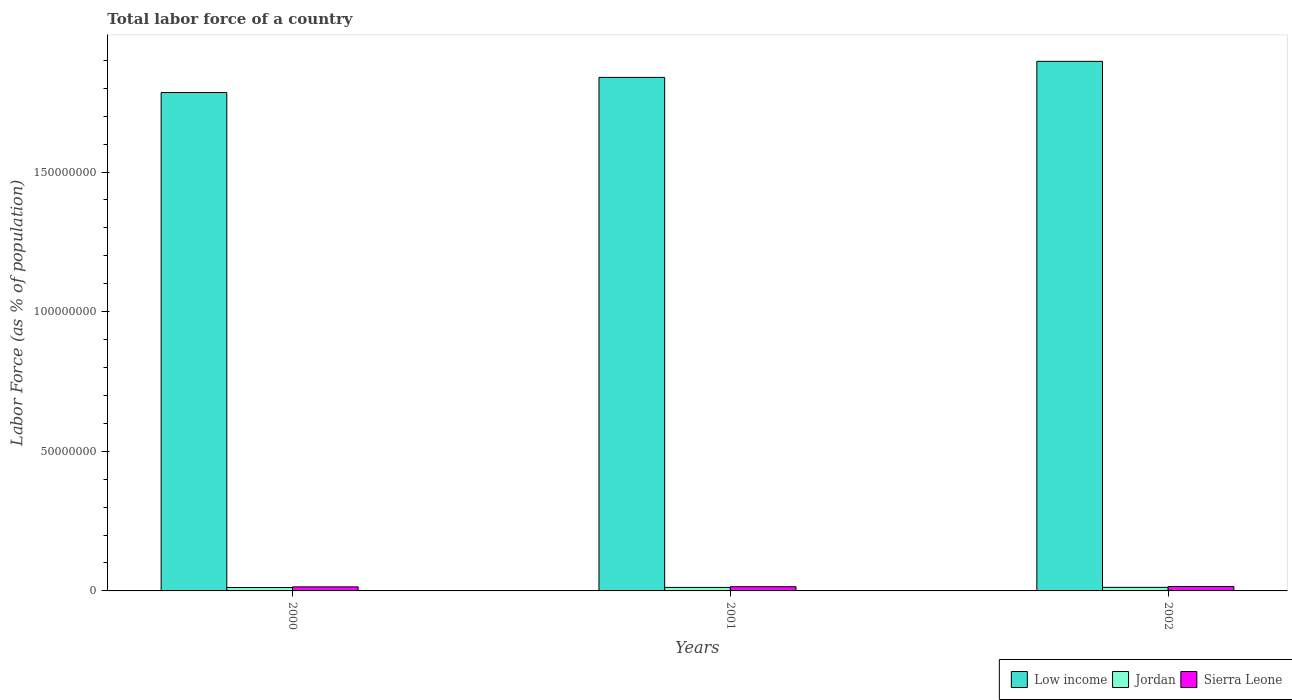Are the number of bars per tick equal to the number of legend labels?
Your answer should be compact. Yes. Are the number of bars on each tick of the X-axis equal?
Give a very brief answer. Yes. What is the label of the 2nd group of bars from the left?
Ensure brevity in your answer.  2001. What is the percentage of labor force in Sierra Leone in 2002?
Provide a short and direct response. 1.59e+06. Across all years, what is the maximum percentage of labor force in Sierra Leone?
Provide a succinct answer. 1.59e+06. Across all years, what is the minimum percentage of labor force in Sierra Leone?
Give a very brief answer. 1.45e+06. In which year was the percentage of labor force in Jordan maximum?
Keep it short and to the point. 2002. What is the total percentage of labor force in Jordan in the graph?
Offer a very short reply. 3.75e+06. What is the difference between the percentage of labor force in Low income in 2000 and that in 2001?
Ensure brevity in your answer.  -5.43e+06. What is the difference between the percentage of labor force in Jordan in 2000 and the percentage of labor force in Low income in 2002?
Ensure brevity in your answer.  -1.88e+08. What is the average percentage of labor force in Sierra Leone per year?
Give a very brief answer. 1.52e+06. In the year 2000, what is the difference between the percentage of labor force in Sierra Leone and percentage of labor force in Low income?
Provide a succinct answer. -1.77e+08. What is the ratio of the percentage of labor force in Jordan in 2000 to that in 2001?
Provide a short and direct response. 0.97. Is the difference between the percentage of labor force in Sierra Leone in 2001 and 2002 greater than the difference between the percentage of labor force in Low income in 2001 and 2002?
Your answer should be compact. Yes. What is the difference between the highest and the second highest percentage of labor force in Jordan?
Offer a very short reply. 2.31e+04. What is the difference between the highest and the lowest percentage of labor force in Low income?
Provide a succinct answer. 1.12e+07. What does the 2nd bar from the left in 2002 represents?
Your answer should be compact. Jordan. What does the 2nd bar from the right in 2001 represents?
Keep it short and to the point. Jordan. Is it the case that in every year, the sum of the percentage of labor force in Sierra Leone and percentage of labor force in Jordan is greater than the percentage of labor force in Low income?
Your response must be concise. No. How many bars are there?
Offer a terse response. 9. Are all the bars in the graph horizontal?
Your response must be concise. No. How many years are there in the graph?
Provide a short and direct response. 3. What is the difference between two consecutive major ticks on the Y-axis?
Offer a terse response. 5.00e+07. Are the values on the major ticks of Y-axis written in scientific E-notation?
Offer a very short reply. No. Does the graph contain any zero values?
Your answer should be compact. No. Does the graph contain grids?
Your answer should be very brief. No. Where does the legend appear in the graph?
Offer a very short reply. Bottom right. How many legend labels are there?
Give a very brief answer. 3. How are the legend labels stacked?
Provide a succinct answer. Horizontal. What is the title of the graph?
Provide a short and direct response. Total labor force of a country. Does "Belgium" appear as one of the legend labels in the graph?
Ensure brevity in your answer.  No. What is the label or title of the X-axis?
Provide a succinct answer. Years. What is the label or title of the Y-axis?
Offer a terse response. Labor Force (as % of population). What is the Labor Force (as % of population) in Low income in 2000?
Your response must be concise. 1.78e+08. What is the Labor Force (as % of population) of Jordan in 2000?
Your answer should be compact. 1.22e+06. What is the Labor Force (as % of population) in Sierra Leone in 2000?
Keep it short and to the point. 1.45e+06. What is the Labor Force (as % of population) in Low income in 2001?
Your answer should be very brief. 1.84e+08. What is the Labor Force (as % of population) in Jordan in 2001?
Your answer should be very brief. 1.25e+06. What is the Labor Force (as % of population) in Sierra Leone in 2001?
Make the answer very short. 1.51e+06. What is the Labor Force (as % of population) in Low income in 2002?
Provide a succinct answer. 1.90e+08. What is the Labor Force (as % of population) of Jordan in 2002?
Your response must be concise. 1.28e+06. What is the Labor Force (as % of population) of Sierra Leone in 2002?
Offer a very short reply. 1.59e+06. Across all years, what is the maximum Labor Force (as % of population) in Low income?
Provide a short and direct response. 1.90e+08. Across all years, what is the maximum Labor Force (as % of population) in Jordan?
Offer a very short reply. 1.28e+06. Across all years, what is the maximum Labor Force (as % of population) of Sierra Leone?
Offer a terse response. 1.59e+06. Across all years, what is the minimum Labor Force (as % of population) in Low income?
Your answer should be compact. 1.78e+08. Across all years, what is the minimum Labor Force (as % of population) in Jordan?
Offer a very short reply. 1.22e+06. Across all years, what is the minimum Labor Force (as % of population) in Sierra Leone?
Your response must be concise. 1.45e+06. What is the total Labor Force (as % of population) of Low income in the graph?
Make the answer very short. 5.52e+08. What is the total Labor Force (as % of population) of Jordan in the graph?
Your answer should be compact. 3.75e+06. What is the total Labor Force (as % of population) of Sierra Leone in the graph?
Provide a succinct answer. 4.55e+06. What is the difference between the Labor Force (as % of population) of Low income in 2000 and that in 2001?
Give a very brief answer. -5.43e+06. What is the difference between the Labor Force (as % of population) in Jordan in 2000 and that in 2001?
Provide a succinct answer. -3.47e+04. What is the difference between the Labor Force (as % of population) in Sierra Leone in 2000 and that in 2001?
Ensure brevity in your answer.  -5.82e+04. What is the difference between the Labor Force (as % of population) of Low income in 2000 and that in 2002?
Provide a succinct answer. -1.12e+07. What is the difference between the Labor Force (as % of population) in Jordan in 2000 and that in 2002?
Your response must be concise. -5.78e+04. What is the difference between the Labor Force (as % of population) of Sierra Leone in 2000 and that in 2002?
Make the answer very short. -1.34e+05. What is the difference between the Labor Force (as % of population) in Low income in 2001 and that in 2002?
Your answer should be very brief. -5.75e+06. What is the difference between the Labor Force (as % of population) in Jordan in 2001 and that in 2002?
Provide a succinct answer. -2.31e+04. What is the difference between the Labor Force (as % of population) in Sierra Leone in 2001 and that in 2002?
Your response must be concise. -7.57e+04. What is the difference between the Labor Force (as % of population) of Low income in 2000 and the Labor Force (as % of population) of Jordan in 2001?
Provide a short and direct response. 1.77e+08. What is the difference between the Labor Force (as % of population) of Low income in 2000 and the Labor Force (as % of population) of Sierra Leone in 2001?
Offer a very short reply. 1.77e+08. What is the difference between the Labor Force (as % of population) of Jordan in 2000 and the Labor Force (as % of population) of Sierra Leone in 2001?
Offer a terse response. -2.92e+05. What is the difference between the Labor Force (as % of population) of Low income in 2000 and the Labor Force (as % of population) of Jordan in 2002?
Ensure brevity in your answer.  1.77e+08. What is the difference between the Labor Force (as % of population) of Low income in 2000 and the Labor Force (as % of population) of Sierra Leone in 2002?
Keep it short and to the point. 1.77e+08. What is the difference between the Labor Force (as % of population) of Jordan in 2000 and the Labor Force (as % of population) of Sierra Leone in 2002?
Provide a succinct answer. -3.67e+05. What is the difference between the Labor Force (as % of population) in Low income in 2001 and the Labor Force (as % of population) in Jordan in 2002?
Provide a succinct answer. 1.83e+08. What is the difference between the Labor Force (as % of population) in Low income in 2001 and the Labor Force (as % of population) in Sierra Leone in 2002?
Make the answer very short. 1.82e+08. What is the difference between the Labor Force (as % of population) in Jordan in 2001 and the Labor Force (as % of population) in Sierra Leone in 2002?
Make the answer very short. -3.33e+05. What is the average Labor Force (as % of population) in Low income per year?
Keep it short and to the point. 1.84e+08. What is the average Labor Force (as % of population) of Jordan per year?
Keep it short and to the point. 1.25e+06. What is the average Labor Force (as % of population) of Sierra Leone per year?
Provide a succinct answer. 1.52e+06. In the year 2000, what is the difference between the Labor Force (as % of population) of Low income and Labor Force (as % of population) of Jordan?
Offer a terse response. 1.77e+08. In the year 2000, what is the difference between the Labor Force (as % of population) of Low income and Labor Force (as % of population) of Sierra Leone?
Keep it short and to the point. 1.77e+08. In the year 2000, what is the difference between the Labor Force (as % of population) of Jordan and Labor Force (as % of population) of Sierra Leone?
Your answer should be very brief. -2.33e+05. In the year 2001, what is the difference between the Labor Force (as % of population) in Low income and Labor Force (as % of population) in Jordan?
Offer a very short reply. 1.83e+08. In the year 2001, what is the difference between the Labor Force (as % of population) of Low income and Labor Force (as % of population) of Sierra Leone?
Your response must be concise. 1.82e+08. In the year 2001, what is the difference between the Labor Force (as % of population) in Jordan and Labor Force (as % of population) in Sierra Leone?
Ensure brevity in your answer.  -2.57e+05. In the year 2002, what is the difference between the Labor Force (as % of population) of Low income and Labor Force (as % of population) of Jordan?
Keep it short and to the point. 1.88e+08. In the year 2002, what is the difference between the Labor Force (as % of population) of Low income and Labor Force (as % of population) of Sierra Leone?
Ensure brevity in your answer.  1.88e+08. In the year 2002, what is the difference between the Labor Force (as % of population) of Jordan and Labor Force (as % of population) of Sierra Leone?
Offer a terse response. -3.09e+05. What is the ratio of the Labor Force (as % of population) of Low income in 2000 to that in 2001?
Provide a succinct answer. 0.97. What is the ratio of the Labor Force (as % of population) of Jordan in 2000 to that in 2001?
Keep it short and to the point. 0.97. What is the ratio of the Labor Force (as % of population) in Sierra Leone in 2000 to that in 2001?
Provide a short and direct response. 0.96. What is the ratio of the Labor Force (as % of population) of Low income in 2000 to that in 2002?
Your response must be concise. 0.94. What is the ratio of the Labor Force (as % of population) in Jordan in 2000 to that in 2002?
Your response must be concise. 0.95. What is the ratio of the Labor Force (as % of population) of Sierra Leone in 2000 to that in 2002?
Provide a succinct answer. 0.92. What is the ratio of the Labor Force (as % of population) of Low income in 2001 to that in 2002?
Give a very brief answer. 0.97. What is the ratio of the Labor Force (as % of population) in Jordan in 2001 to that in 2002?
Offer a very short reply. 0.98. What is the ratio of the Labor Force (as % of population) of Sierra Leone in 2001 to that in 2002?
Provide a succinct answer. 0.95. What is the difference between the highest and the second highest Labor Force (as % of population) of Low income?
Your answer should be very brief. 5.75e+06. What is the difference between the highest and the second highest Labor Force (as % of population) in Jordan?
Offer a very short reply. 2.31e+04. What is the difference between the highest and the second highest Labor Force (as % of population) in Sierra Leone?
Offer a terse response. 7.57e+04. What is the difference between the highest and the lowest Labor Force (as % of population) in Low income?
Offer a terse response. 1.12e+07. What is the difference between the highest and the lowest Labor Force (as % of population) of Jordan?
Make the answer very short. 5.78e+04. What is the difference between the highest and the lowest Labor Force (as % of population) in Sierra Leone?
Ensure brevity in your answer.  1.34e+05. 